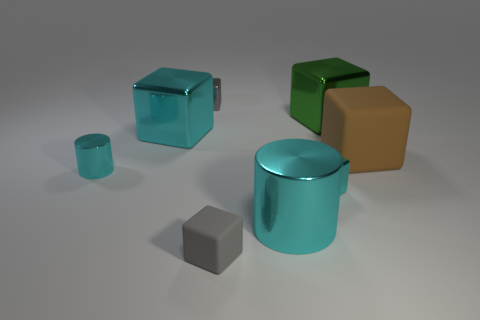Is the number of large cyan cubes that are on the left side of the big cylinder greater than the number of large red metal cubes?
Provide a short and direct response. Yes. What is the shape of the metal thing behind the green metallic block?
Your response must be concise. Cube. How many other things are there of the same shape as the brown matte object?
Your answer should be very brief. 5. Are the big object that is in front of the big rubber thing and the large brown cube made of the same material?
Make the answer very short. No. Are there an equal number of brown blocks that are to the right of the large brown block and large brown matte blocks that are in front of the tiny cyan cylinder?
Make the answer very short. Yes. There is a block that is to the right of the green metal block; what size is it?
Ensure brevity in your answer.  Large. Is there a block made of the same material as the large brown thing?
Your answer should be compact. Yes. Is the color of the small metallic cube that is on the right side of the gray metallic cube the same as the large cylinder?
Provide a short and direct response. Yes. Are there the same number of large cyan metal things that are behind the big cyan cube and large brown balls?
Provide a short and direct response. Yes. Is there a cylinder of the same color as the tiny matte cube?
Keep it short and to the point. No. 